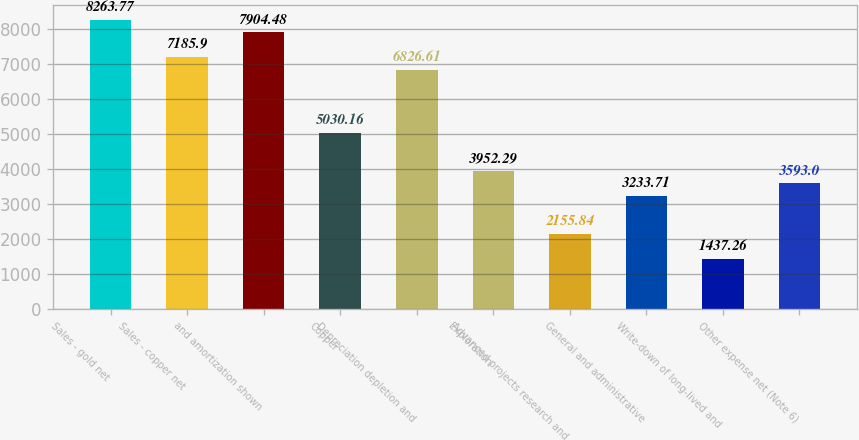<chart> <loc_0><loc_0><loc_500><loc_500><bar_chart><fcel>Sales - gold net<fcel>Sales - copper net<fcel>and amortization shown<fcel>Copper<fcel>Depreciation depletion and<fcel>Exploration<fcel>Advanced projects research and<fcel>General and administrative<fcel>Write-down of long-lived and<fcel>Other expense net (Note 6)<nl><fcel>8263.77<fcel>7185.9<fcel>7904.48<fcel>5030.16<fcel>6826.61<fcel>3952.29<fcel>2155.84<fcel>3233.71<fcel>1437.26<fcel>3593<nl></chart> 